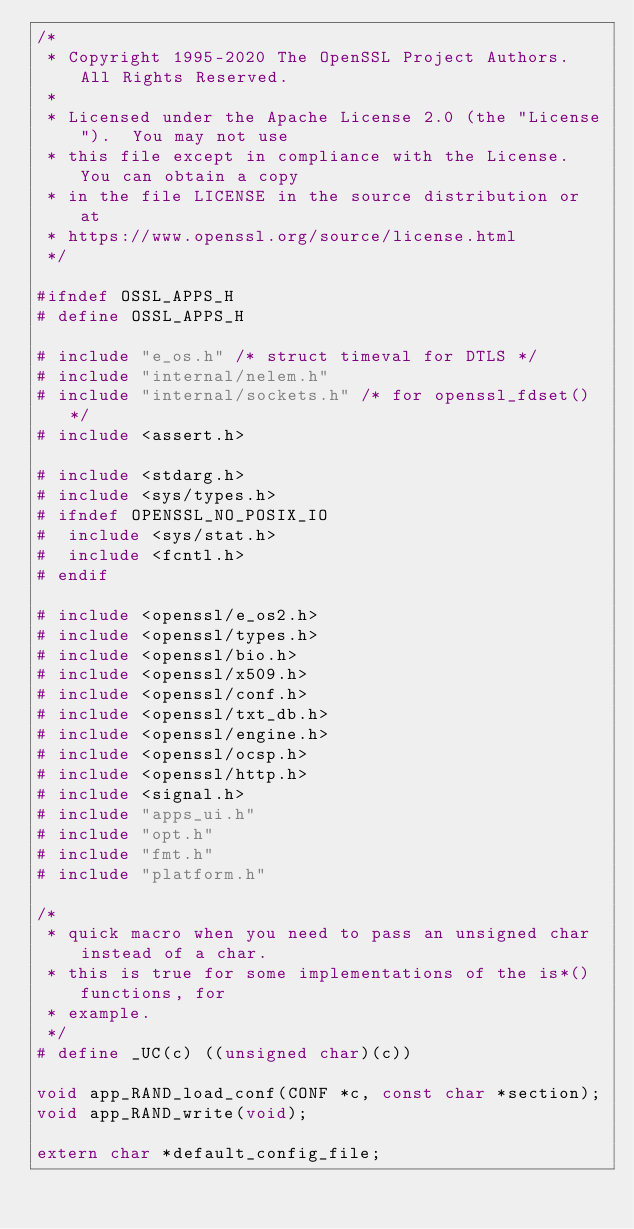Convert code to text. <code><loc_0><loc_0><loc_500><loc_500><_C_>/*
 * Copyright 1995-2020 The OpenSSL Project Authors. All Rights Reserved.
 *
 * Licensed under the Apache License 2.0 (the "License").  You may not use
 * this file except in compliance with the License.  You can obtain a copy
 * in the file LICENSE in the source distribution or at
 * https://www.openssl.org/source/license.html
 */

#ifndef OSSL_APPS_H
# define OSSL_APPS_H

# include "e_os.h" /* struct timeval for DTLS */
# include "internal/nelem.h"
# include "internal/sockets.h" /* for openssl_fdset() */
# include <assert.h>

# include <stdarg.h>
# include <sys/types.h>
# ifndef OPENSSL_NO_POSIX_IO
#  include <sys/stat.h>
#  include <fcntl.h>
# endif

# include <openssl/e_os2.h>
# include <openssl/types.h>
# include <openssl/bio.h>
# include <openssl/x509.h>
# include <openssl/conf.h>
# include <openssl/txt_db.h>
# include <openssl/engine.h>
# include <openssl/ocsp.h>
# include <openssl/http.h>
# include <signal.h>
# include "apps_ui.h"
# include "opt.h"
# include "fmt.h"
# include "platform.h"

/*
 * quick macro when you need to pass an unsigned char instead of a char.
 * this is true for some implementations of the is*() functions, for
 * example.
 */
# define _UC(c) ((unsigned char)(c))

void app_RAND_load_conf(CONF *c, const char *section);
void app_RAND_write(void);

extern char *default_config_file;</code> 